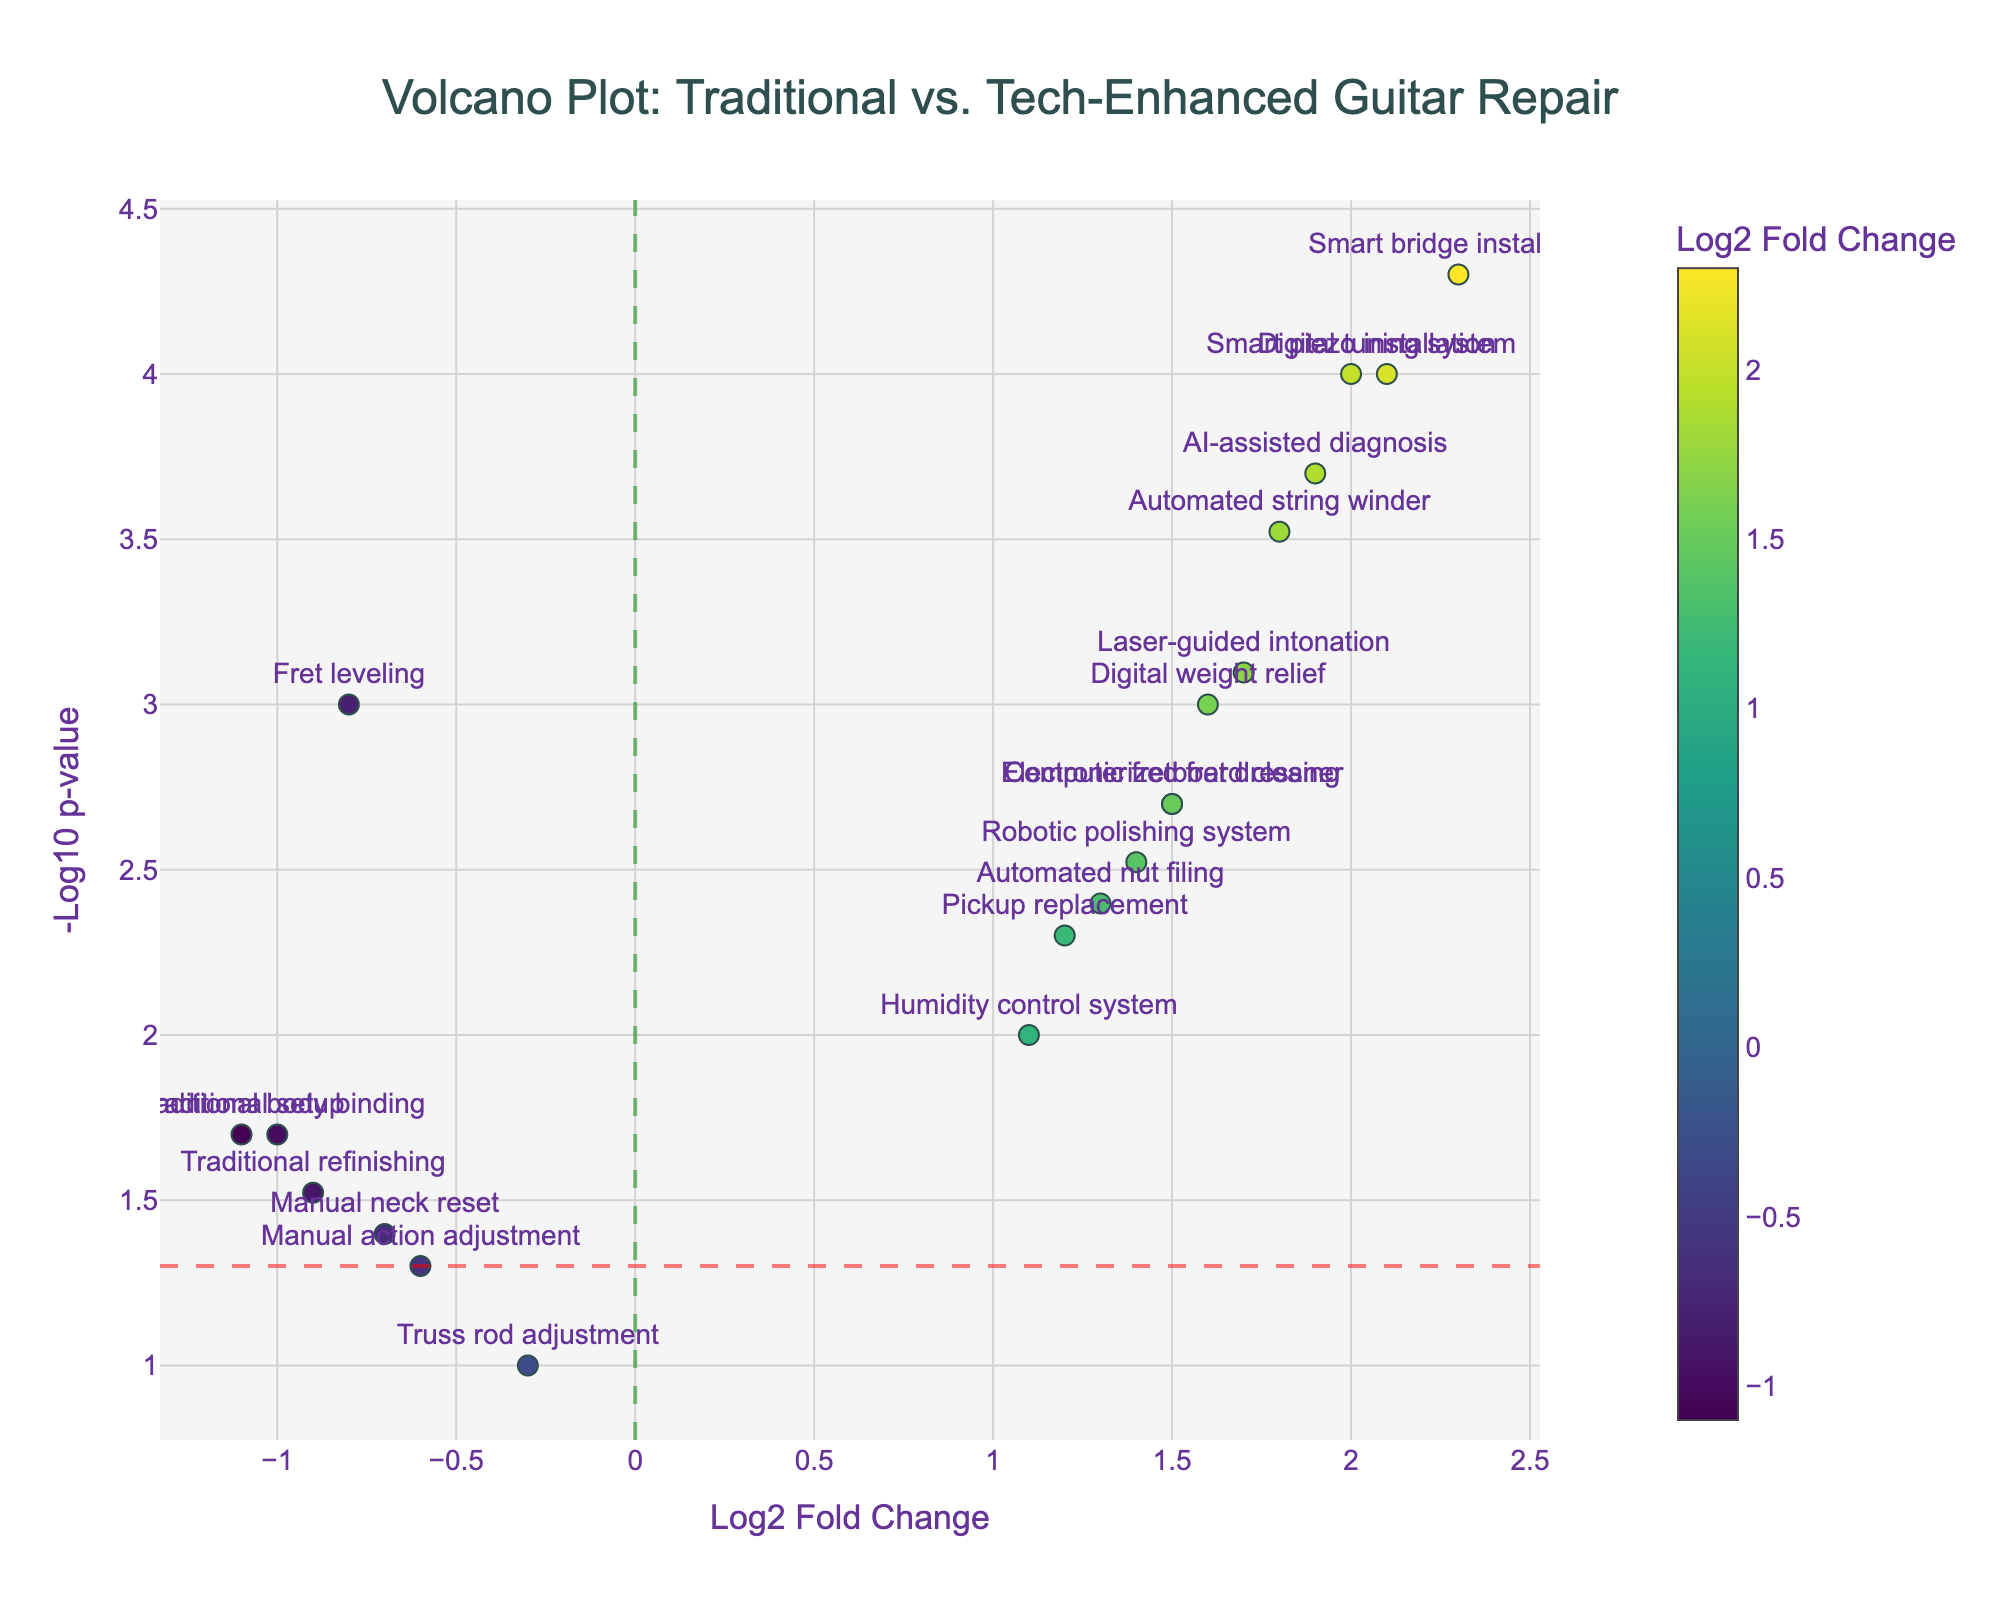What's the title of the plot? The title of the plot is usually positioned at the top. Here, it states, "Volcano Plot: Traditional vs. Tech-Enhanced Guitar Repair."
Answer: Volcano Plot: Traditional vs. Tech-Enhanced Guitar Repair How many data points have a log2 fold change greater than 1? To determine this, count the points on the right side of the vertical line x=1 (excluding the line itself). The relevant data points are Pickup replacement, Digital tuning system, Automated string winder, Electronic fretboard cleaner, Smart bridge installation, AI-assisted diagnosis, Laser-guided intonation, Robotic polishing system, Humidity control system, Automated nut filing, Digital weight relief, Smart piezo installation, Computerized fret dressing, so there are 13 such data points.
Answer: 13 Which repair type has the highest significance? The repair type with the highest significance will have the highest -log10(p-value), i.e., the point farthest up on the y-axis. The highest point corresponds to Smart bridge installation.
Answer: Smart bridge installation Compare the significance and fold change of Traditional setup and Automated string winder. To compare, look at both the y-values (-log10(p-value)) and the x-values (log2 fold change) of these points. Traditional setup has a negative fold change (-1.1) and a (lower) y-value (~1.7), while Automated string winder has a positive fold change (1.8) and a (higher) y-value (~3.5). Thus, Automated string winder is more significant and has a higher positive fold change.
Answer: Automated string winder is more significant and has a higher positive fold change What is the significance threshold indicated by the horizontal line? The horizontal line is drawn at y = -log10(0.05). Compute -log10(0.05), which equals approximately 1.3.
Answer: 1.3 What are the fold change and p-value for Manual neck reset? Hover over or locate the Manual neck reset point on the plot. It's x-value (log2 fold change) is -0.7 and y-value corresponds to a p-value of 0.04 (since -log10(0.04) ≈ 1.40).
Answer: Fold change: -0.7, p-value: 0.04 Which repair type has the lowest positive log2 fold change? Check the lowest x-value greater than zero. Here, Humidity control system has a log2 fold change of 1.1.
Answer: Humidity control system Identify all the repair types that are significant (p-value < 0.05) and have positive log2 fold changes. Significant repairs are those above the y = 1.3 line, and with positive log2 fold changes (right side of x=0). The data points are Pickup replacement, Digital tuning system, Automated string winder, Electronic fretboard cleaner, Smart bridge installation, AI-assisted diagnosis, Laser-guided intonation, Robotic polishing system, Humidity control system, Automated nut filing, Digital weight relief, Smart piezo installation, and Computerized fret dressing.
Answer: Pickup replacement, Digital tuning system, Automated string winder, Electronic fretboard cleaner, Smart bridge installation, AI-assisted diagnosis, Laser-guided intonation, Robotic polishing system, Humidity control system, Automated nut filing, Digital weight relief, Smart piezo installation, Computerized fret dressing 